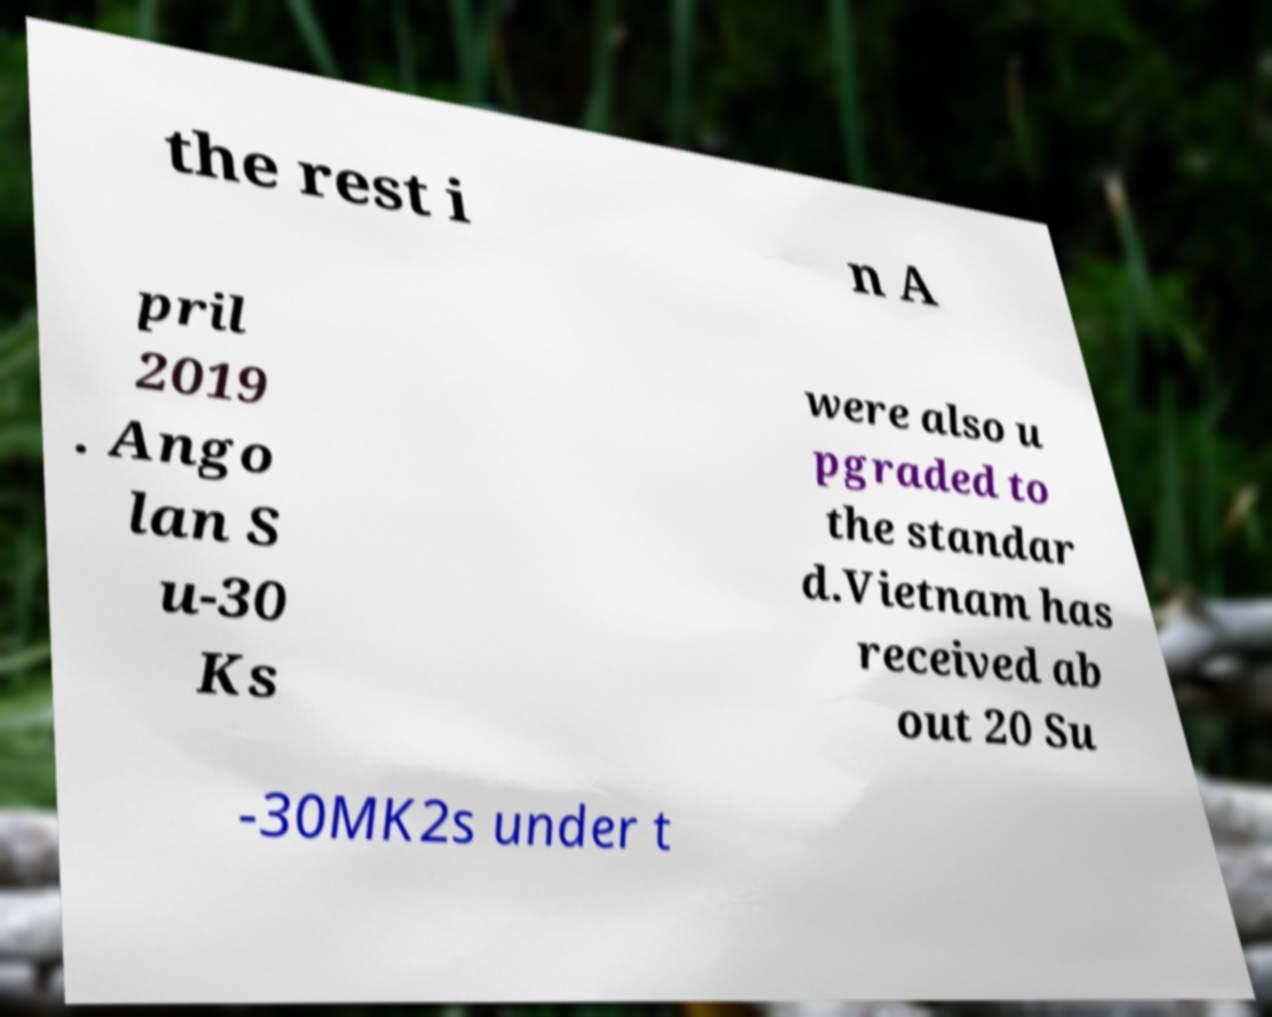What messages or text are displayed in this image? I need them in a readable, typed format. the rest i n A pril 2019 . Ango lan S u-30 Ks were also u pgraded to the standar d.Vietnam has received ab out 20 Su -30MK2s under t 